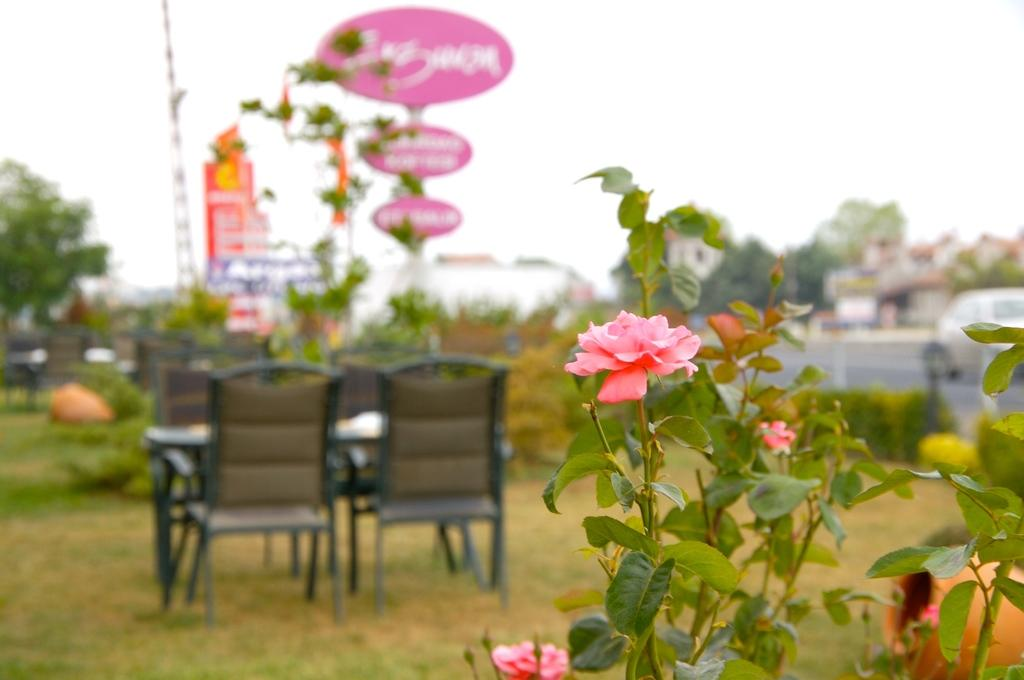What type of furniture is present in the image? There are chairs and a table in the image. Where are the chairs and table located? The chairs and table are on the ground in the image. What type of vegetation can be seen in the image? There is a flower plant and a tree in the image. What type of underwear is hanging on the tree in the image? There is no underwear present in the image; it only features chairs, a table, a flower plant, and a tree. 